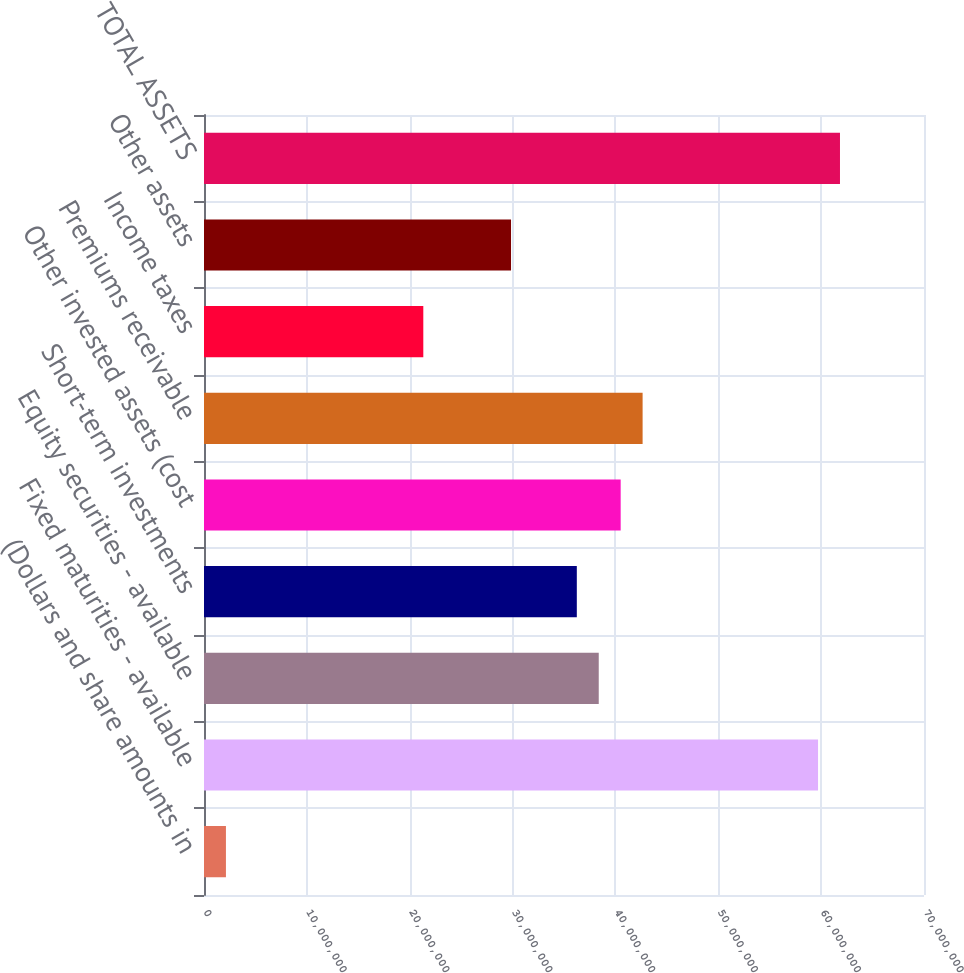Convert chart. <chart><loc_0><loc_0><loc_500><loc_500><bar_chart><fcel>(Dollars and share amounts in<fcel>Fixed maturities - available<fcel>Equity securities - available<fcel>Short-term investments<fcel>Other invested assets (cost<fcel>Premiums receivable<fcel>Income taxes<fcel>Other assets<fcel>TOTAL ASSETS<nl><fcel>2.13277e+06<fcel>5.9699e+07<fcel>3.83782e+07<fcel>3.62461e+07<fcel>4.05102e+07<fcel>4.26423e+07<fcel>2.13215e+07<fcel>2.98498e+07<fcel>6.18311e+07<nl></chart> 